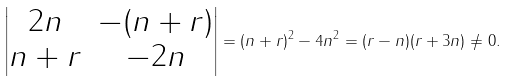Convert formula to latex. <formula><loc_0><loc_0><loc_500><loc_500>\begin{vmatrix} 2 n & - ( n + r ) \\ n + r & - 2 n \end{vmatrix} = ( n + r ) ^ { 2 } - 4 n ^ { 2 } = ( r - n ) ( r + 3 n ) \ne 0 .</formula> 